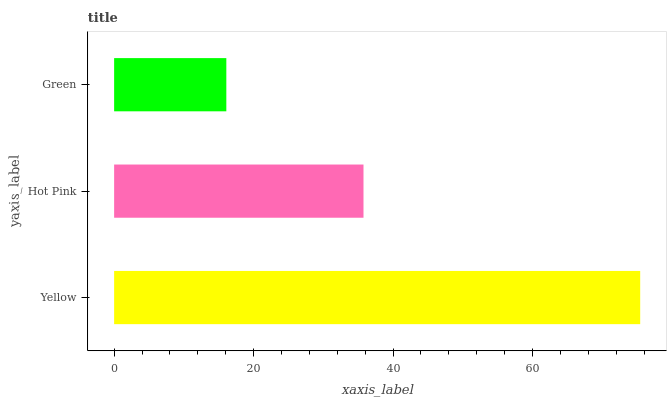Is Green the minimum?
Answer yes or no. Yes. Is Yellow the maximum?
Answer yes or no. Yes. Is Hot Pink the minimum?
Answer yes or no. No. Is Hot Pink the maximum?
Answer yes or no. No. Is Yellow greater than Hot Pink?
Answer yes or no. Yes. Is Hot Pink less than Yellow?
Answer yes or no. Yes. Is Hot Pink greater than Yellow?
Answer yes or no. No. Is Yellow less than Hot Pink?
Answer yes or no. No. Is Hot Pink the high median?
Answer yes or no. Yes. Is Hot Pink the low median?
Answer yes or no. Yes. Is Yellow the high median?
Answer yes or no. No. Is Green the low median?
Answer yes or no. No. 